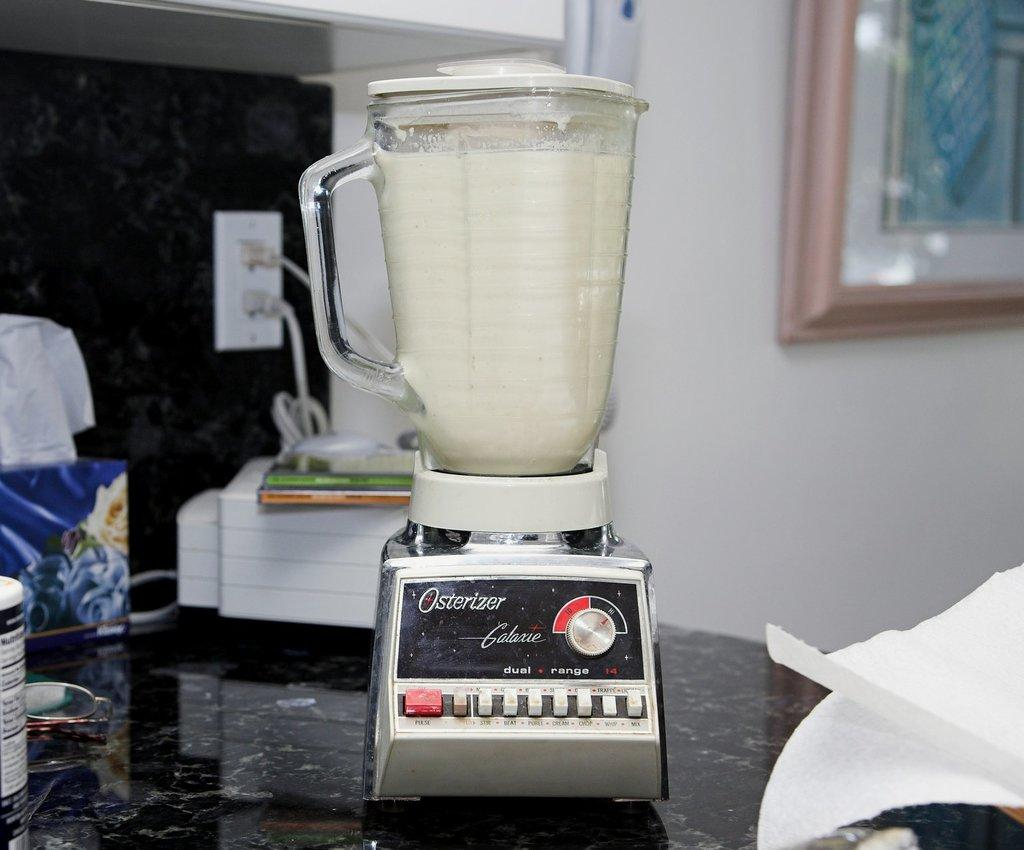<image>
Describe the image concisely. An Osterizer blender is blending a white liquid 